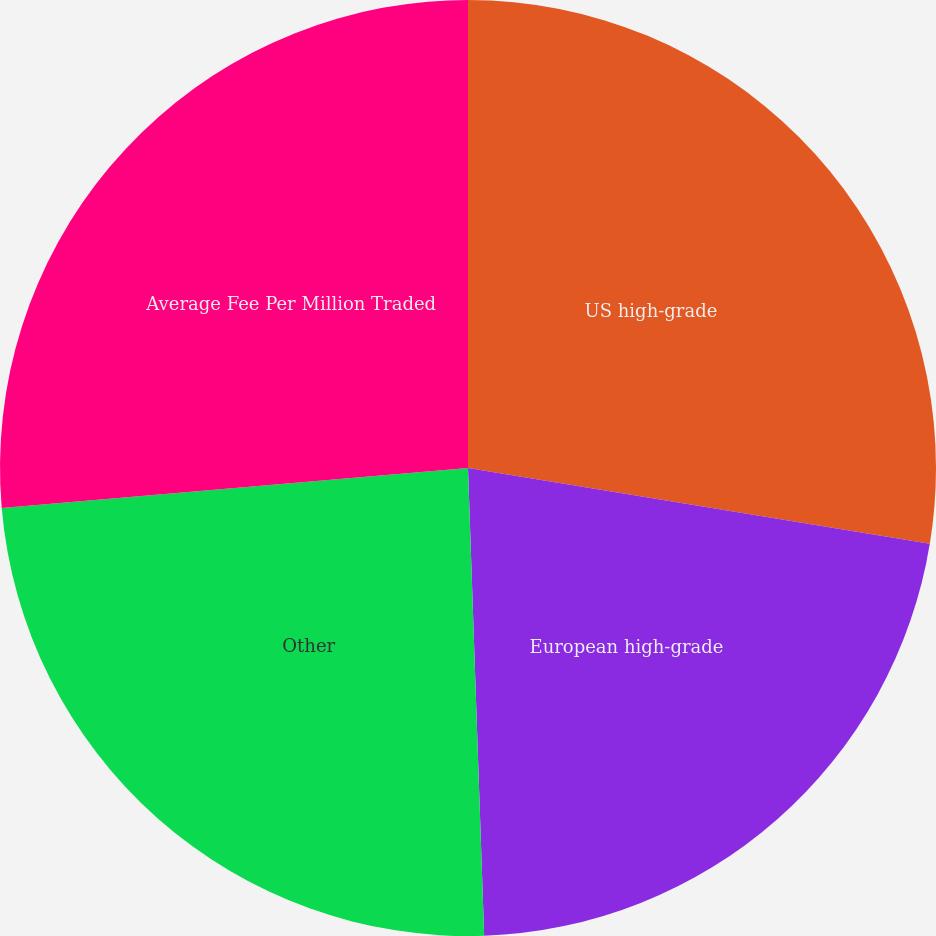Convert chart. <chart><loc_0><loc_0><loc_500><loc_500><pie_chart><fcel>US high-grade<fcel>European high-grade<fcel>Other<fcel>Average Fee Per Million Traded<nl><fcel>27.59%<fcel>21.86%<fcel>24.19%<fcel>26.36%<nl></chart> 